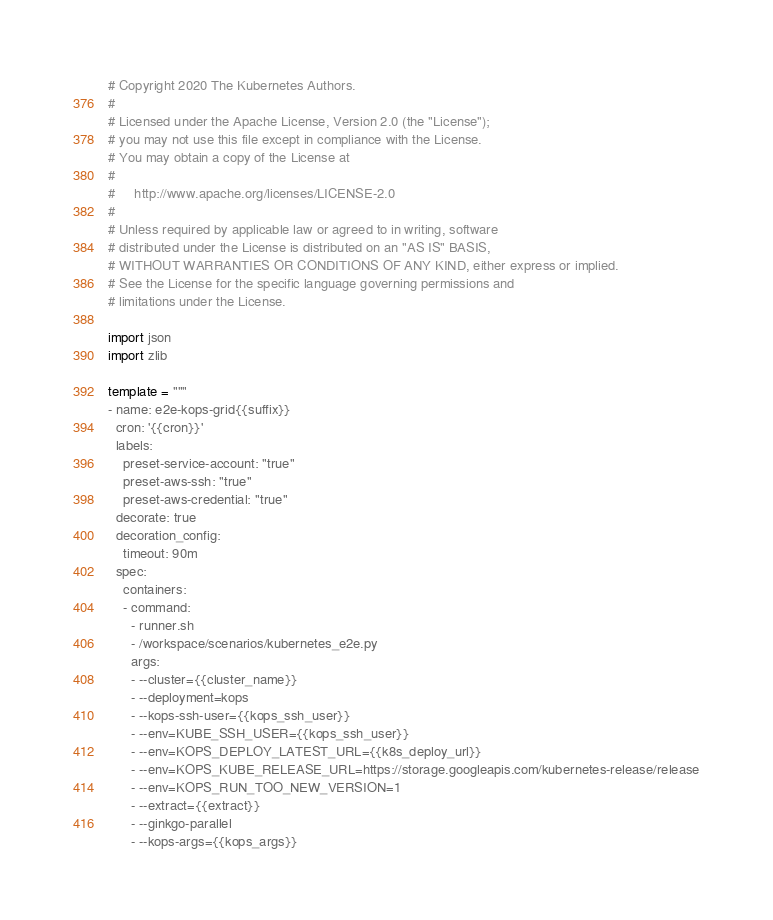Convert code to text. <code><loc_0><loc_0><loc_500><loc_500><_Python_># Copyright 2020 The Kubernetes Authors.
#
# Licensed under the Apache License, Version 2.0 (the "License");
# you may not use this file except in compliance with the License.
# You may obtain a copy of the License at
#
#     http://www.apache.org/licenses/LICENSE-2.0
#
# Unless required by applicable law or agreed to in writing, software
# distributed under the License is distributed on an "AS IS" BASIS,
# WITHOUT WARRANTIES OR CONDITIONS OF ANY KIND, either express or implied.
# See the License for the specific language governing permissions and
# limitations under the License.

import json
import zlib

template = """
- name: e2e-kops-grid{{suffix}}
  cron: '{{cron}}'
  labels:
    preset-service-account: "true"
    preset-aws-ssh: "true"
    preset-aws-credential: "true"
  decorate: true
  decoration_config:
    timeout: 90m
  spec:
    containers:
    - command:
      - runner.sh
      - /workspace/scenarios/kubernetes_e2e.py
      args:
      - --cluster={{cluster_name}}
      - --deployment=kops
      - --kops-ssh-user={{kops_ssh_user}}
      - --env=KUBE_SSH_USER={{kops_ssh_user}}
      - --env=KOPS_DEPLOY_LATEST_URL={{k8s_deploy_url}}
      - --env=KOPS_KUBE_RELEASE_URL=https://storage.googleapis.com/kubernetes-release/release
      - --env=KOPS_RUN_TOO_NEW_VERSION=1
      - --extract={{extract}}
      - --ginkgo-parallel
      - --kops-args={{kops_args}}</code> 